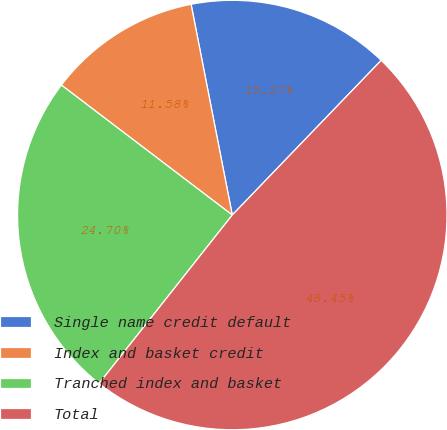Convert chart to OTSL. <chart><loc_0><loc_0><loc_500><loc_500><pie_chart><fcel>Single name credit default<fcel>Index and basket credit<fcel>Tranched index and basket<fcel>Total<nl><fcel>15.27%<fcel>11.58%<fcel>24.7%<fcel>48.45%<nl></chart> 